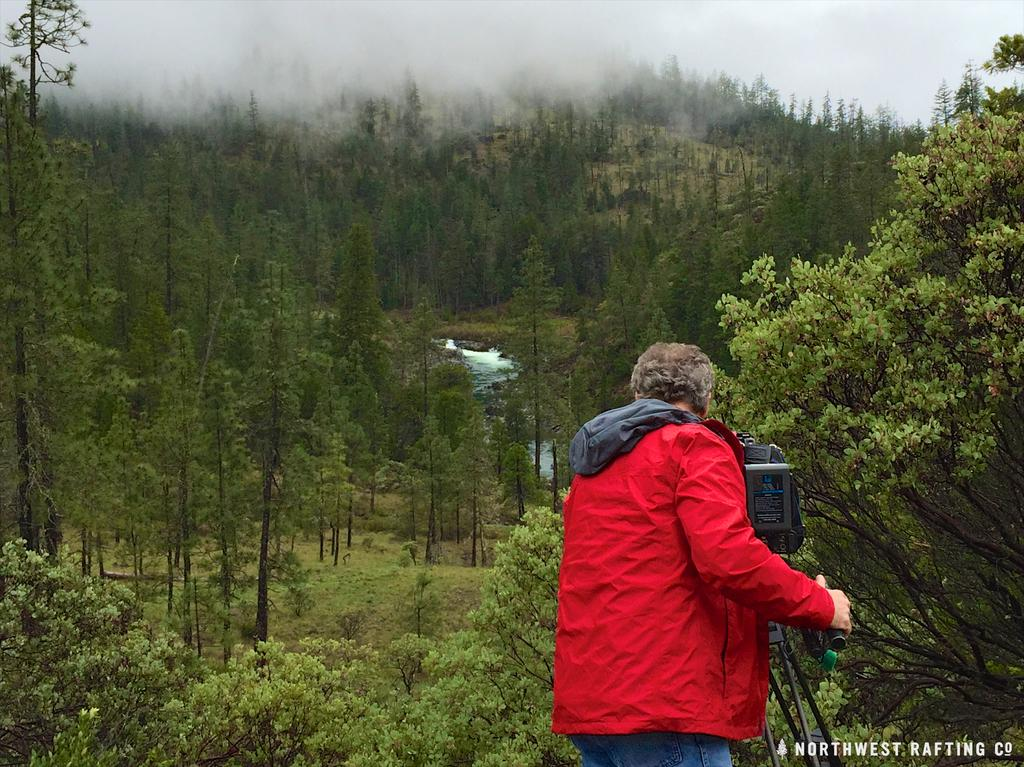What is the main subject of the image? There is a human being in the image. What is the person wearing? The person is wearing a red coat. What type of natural environment is visible in the image? There are trees in the image. What is the weather condition depicted in the image? The top of the image depicts snow. What type of muscle can be seen flexing in the image? There is no muscle visible in the image, as it features a person wearing a red coat in a snowy environment. How many teeth can be seen in the image? There is no indication of teeth in the image, as it focuses on a person wearing a red coat and the surrounding environment. 